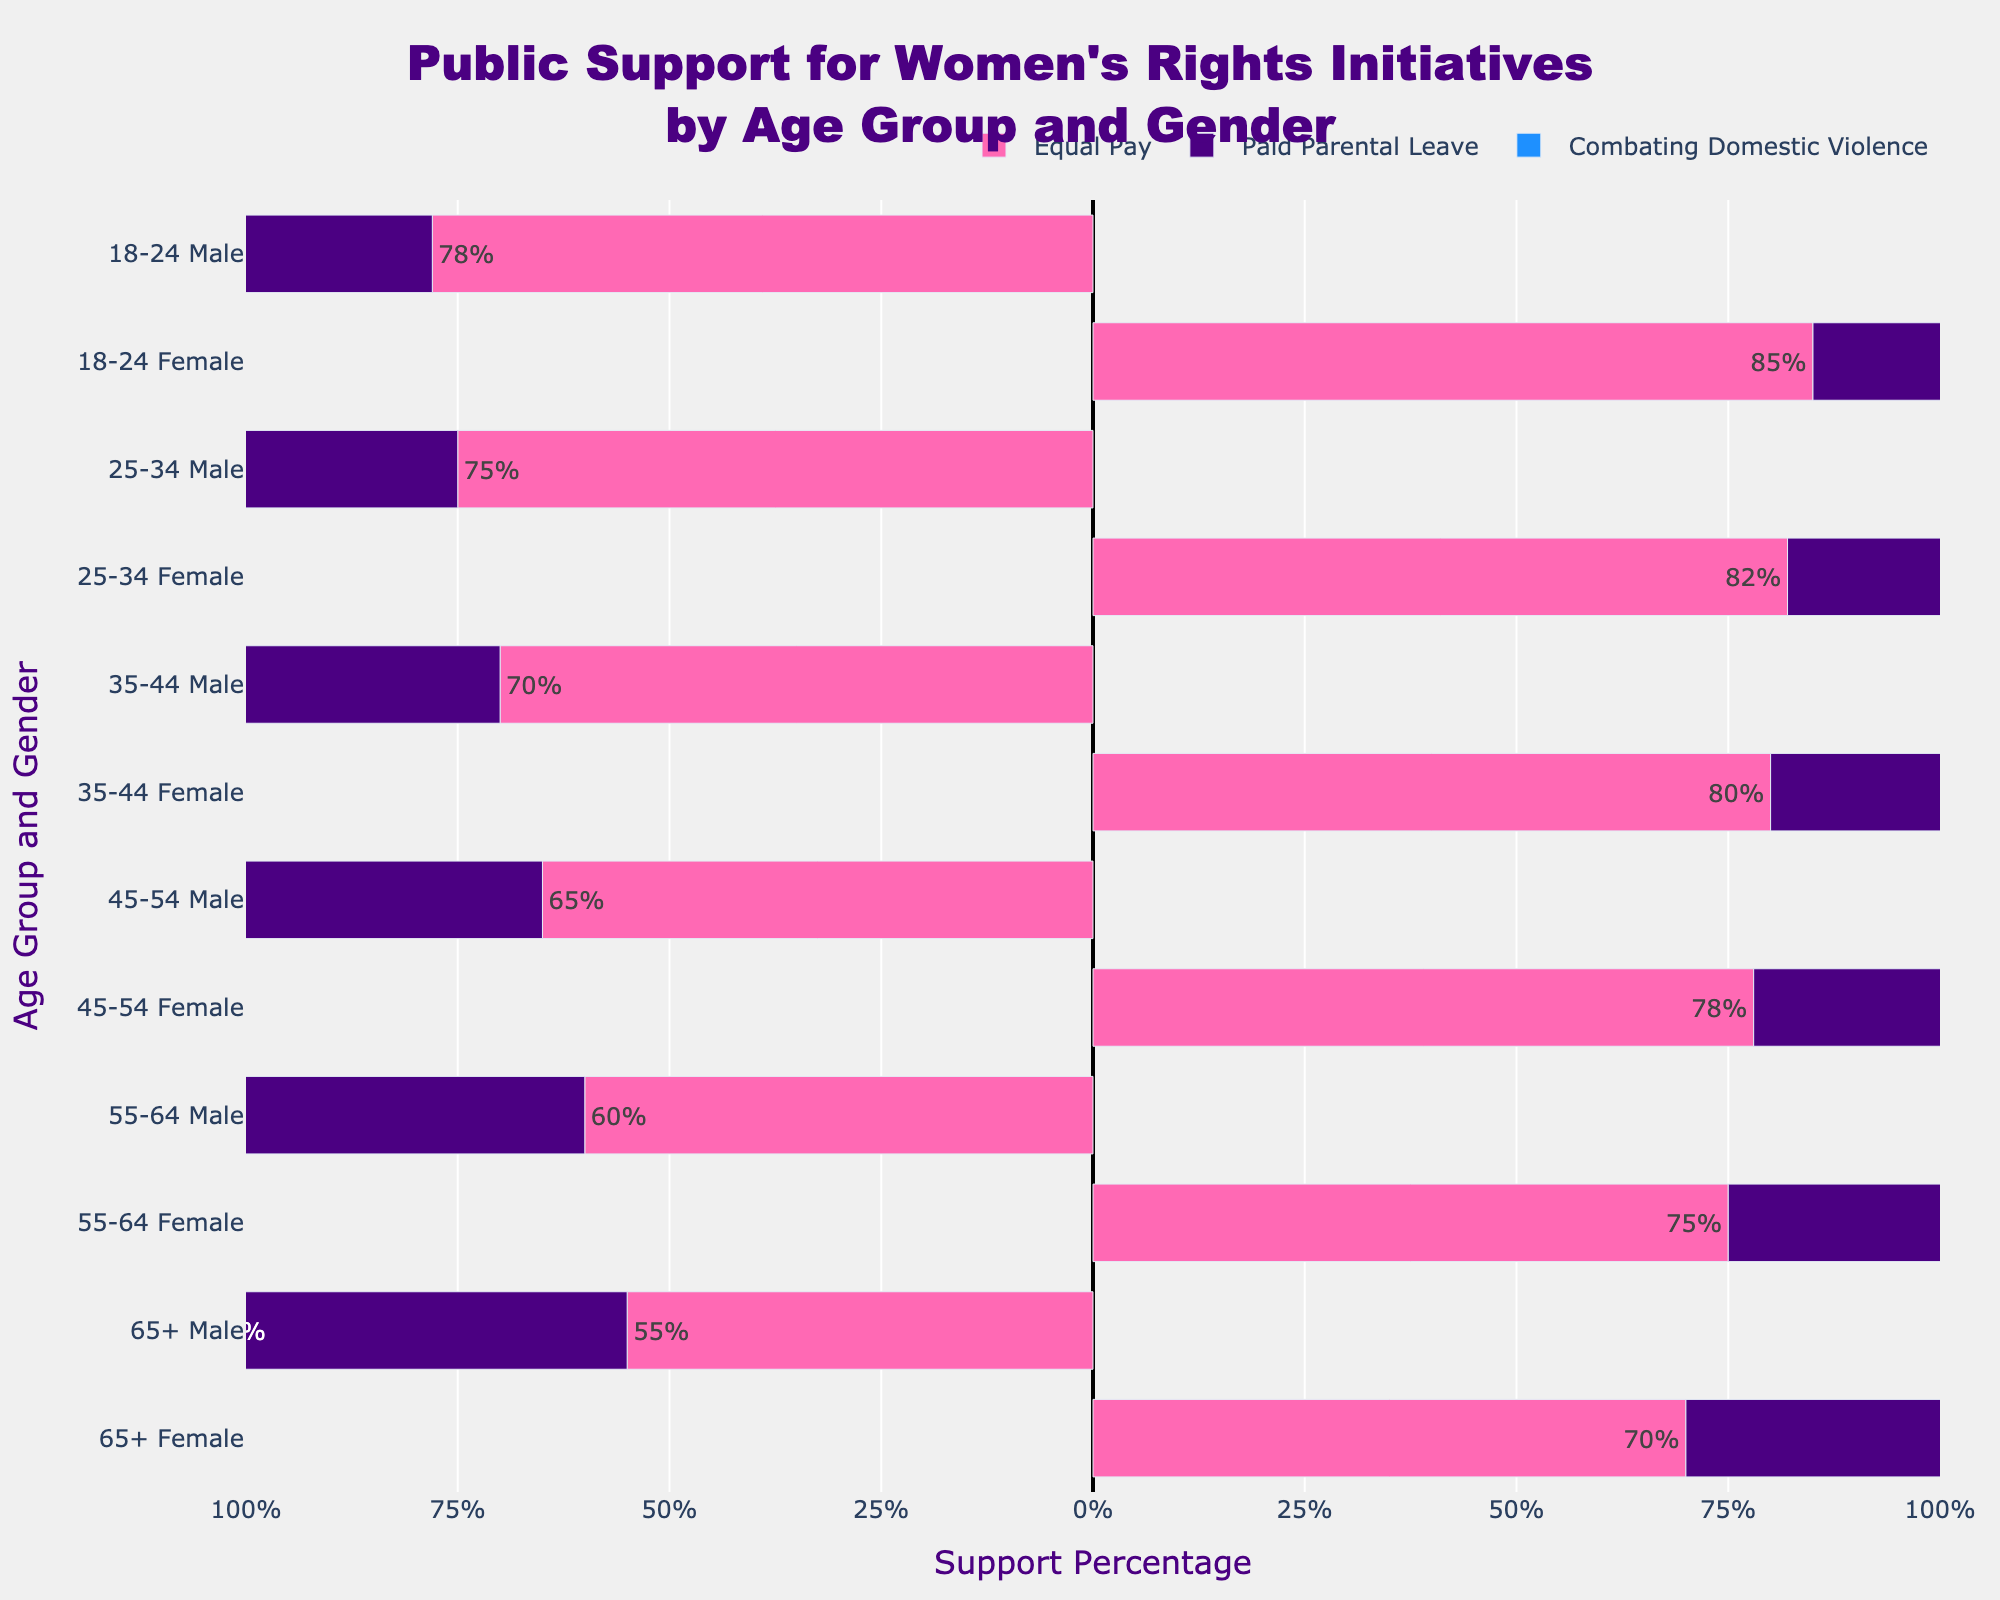Which age group shows the highest support percentage for Equal Pay among females? To find the answer, we look at the bars representing Equal Pay among females in different age groups. The highest percentage is 85%, which corresponds to the 18-24 age group.
Answer: 18-24 age group Compare the support percentages for Paid Parental Leave between males aged 25-34 and 45-54. Which group shows higher support? To determine this, we look at the bars representing Paid Parental Leave for these specific age groups and genders. Males aged 25-34 have 70% support while males aged 45-54 have 60% support. Therefore, 25-34 have higher support.
Answer: 25-34 age group What is the difference in support percentage for Combating Domestic Violence between females aged 35-44 and 65+? First, we identify the support percentages for the specified groups: 86% for females aged 35-44 and 78% for females aged 65+. Then, we calculate the difference: 86 - 78 = 8%.
Answer: 8% Which gender, across the 55-64 age group, shows greater support for Equal Pay? By examining the bars for Equal Pay within the 55-64 age group, it is evident that females have a support percentage of 75%, whereas males have 60%. Therefore, females show greater support.
Answer: Females How does the support for Paid Parental Leave among females aged 18-24 compare to males in the same age group? We look at the support percentages for both gender groups within the 18-24 age range: females show 80% support, while males show 72%. This indicates that females have higher support for Paid Parental Leave.
Answer: Females have higher support Calculate the average support percentage for Combating Domestic Violence among males across all age groups. The support percentages for males in each age group are: 85%, 80%, 77%, 73%, 70%, and 65%. Summing these gives 450, and there are six age groups. The average is 450 / 6 = 75%.
Answer: 75% Which initiative shows the least support among males aged 65+? To answer this, we compare the bars representing different initiatives for males aged 65+: 55% for Equal Pay, 50% for Paid Parental Leave, and 65% for Combating Domestic Violence. The least support is for Paid Parental Leave.
Answer: Paid Parental Leave Identify the initiative with the smallest difference in support percentage between males and females aged 45-54. Evaluating the support percentages for 45-54 age group: Equal Pay (Females 78% - Males 65% = 13%), Paid Parental Leave (Females 74% - Males 60% = 14%), Combating Domestic Violence (Females 84% - Males 73% = 11%). The smallest difference is for Combating Domestic Violence.
Answer: Combating Domestic Violence 